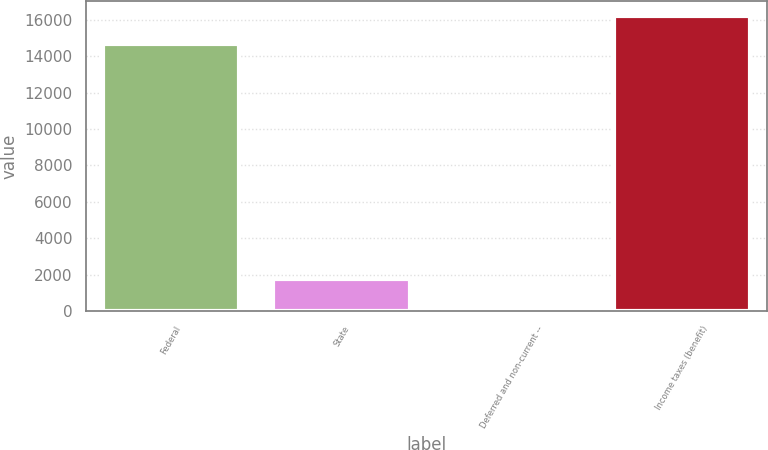Convert chart to OTSL. <chart><loc_0><loc_0><loc_500><loc_500><bar_chart><fcel>Federal<fcel>State<fcel>Deferred and non-current --<fcel>Income taxes (benefit)<nl><fcel>14641<fcel>1767.1<fcel>201<fcel>16207.1<nl></chart> 